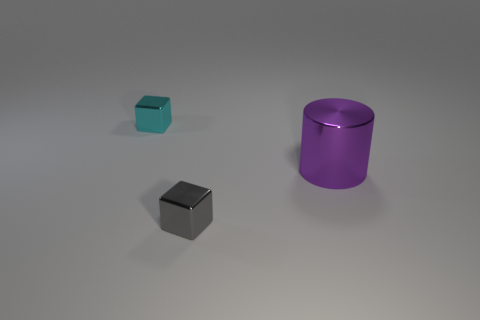There is another tiny cube that is the same material as the small gray cube; what is its color?
Offer a terse response. Cyan. Is the number of big shiny objects that are behind the small cyan metallic block less than the number of metal cylinders that are to the left of the large purple metallic thing?
Give a very brief answer. No. What number of shiny objects are on the left side of the purple cylinder and behind the gray shiny block?
Provide a short and direct response. 1. What material is the large cylinder to the right of the shiny cube that is in front of the purple object?
Keep it short and to the point. Metal. Are there any small brown objects made of the same material as the tiny cyan thing?
Provide a short and direct response. No. What material is the gray block that is the same size as the cyan block?
Offer a very short reply. Metal. What is the size of the metal cube that is right of the cube that is to the left of the tiny object that is to the right of the small cyan block?
Your answer should be very brief. Small. Are there any cyan metallic blocks in front of the tiny block that is on the left side of the gray object?
Your answer should be compact. No. There is a big metallic object; is it the same shape as the metal thing that is in front of the metal cylinder?
Make the answer very short. No. There is a cube that is behind the large purple cylinder; what is its color?
Provide a short and direct response. Cyan. 